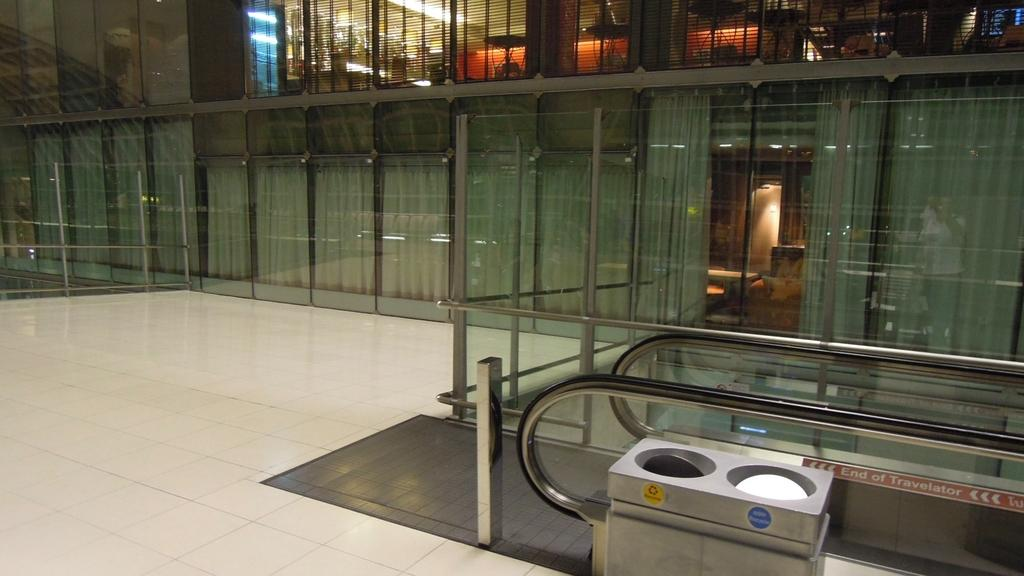<image>
Summarize the visual content of the image. A garbage can in the foreground with a label for recycling. 